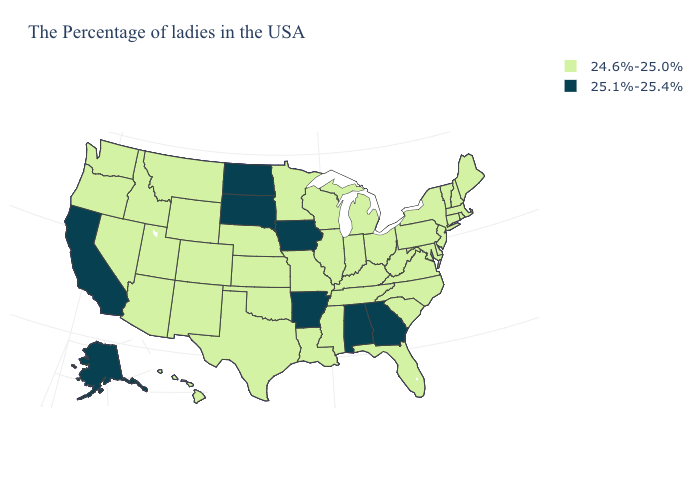Among the states that border California , which have the highest value?
Quick response, please. Arizona, Nevada, Oregon. What is the value of Wisconsin?
Quick response, please. 24.6%-25.0%. What is the lowest value in the USA?
Be succinct. 24.6%-25.0%. What is the highest value in states that border North Dakota?
Keep it brief. 25.1%-25.4%. What is the value of Arkansas?
Keep it brief. 25.1%-25.4%. What is the lowest value in the USA?
Quick response, please. 24.6%-25.0%. Name the states that have a value in the range 25.1%-25.4%?
Be succinct. Georgia, Alabama, Arkansas, Iowa, South Dakota, North Dakota, California, Alaska. What is the value of Ohio?
Answer briefly. 24.6%-25.0%. What is the value of Maryland?
Write a very short answer. 24.6%-25.0%. What is the value of New Jersey?
Keep it brief. 24.6%-25.0%. What is the value of North Dakota?
Concise answer only. 25.1%-25.4%. What is the value of Massachusetts?
Write a very short answer. 24.6%-25.0%. How many symbols are there in the legend?
Answer briefly. 2. 